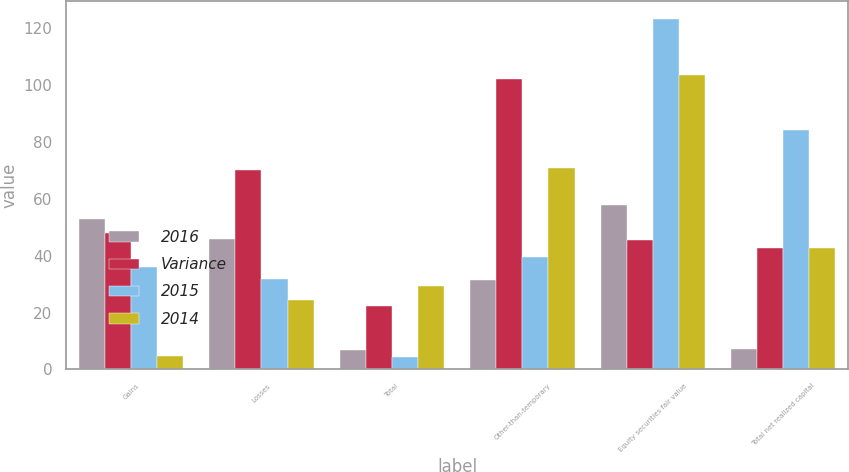<chart> <loc_0><loc_0><loc_500><loc_500><stacked_bar_chart><ecel><fcel>Gains<fcel>Losses<fcel>Total<fcel>Other-than-temporary<fcel>Equity securities fair value<fcel>Total net realized capital<nl><fcel>2016<fcel>52.8<fcel>45.9<fcel>6.9<fcel>31.6<fcel>57.7<fcel>7.2<nl><fcel>Variance<fcel>47.9<fcel>70.2<fcel>22.3<fcel>102.2<fcel>45.6<fcel>42.55<nl><fcel>2015<fcel>36.1<fcel>31.7<fcel>4.4<fcel>39.5<fcel>123.2<fcel>84<nl><fcel>2014<fcel>4.9<fcel>24.3<fcel>29.2<fcel>70.6<fcel>103.3<fcel>42.55<nl></chart> 